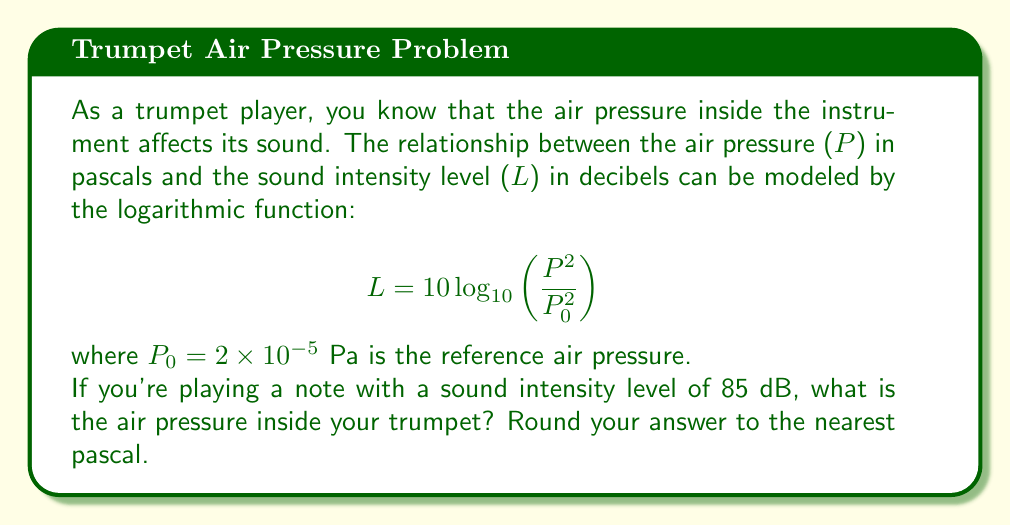Solve this math problem. Let's approach this step-by-step:

1) We're given the formula:
   $$ L = 10 \log_{10}\left(\frac{P^2}{P_0^2}\right) $$

2) We know that:
   - $L = 85$ dB (the sound intensity level)
   - $P_0 = 2 \times 10^{-5}$ Pa (the reference air pressure)
   - We need to solve for $P$

3) Let's substitute the known values into the equation:
   $$ 85 = 10 \log_{10}\left(\frac{P^2}{(2 \times 10^{-5})^2}\right) $$

4) Divide both sides by 10:
   $$ 8.5 = \log_{10}\left(\frac{P^2}{4 \times 10^{-10}}\right) $$

5) Now, we can apply the inverse function (10 to the power) to both sides:
   $$ 10^{8.5} = \frac{P^2}{4 \times 10^{-10}} $$

6) Multiply both sides by $4 \times 10^{-10}$:
   $$ 4 \times 10^{-10} \times 10^{8.5} = P^2 $$

7) Simplify:
   $$ 4 \times 10^{-1.5} = P^2 $$

8) Take the square root of both sides:
   $$ P = \sqrt{4 \times 10^{-1.5}} = 2 \times 10^{-0.75} $$

9) Calculate this value:
   $$ P \approx 0.3557 \text{ Pa} $$

10) Rounding to the nearest pascal:
    $$ P \approx 0 \text{ Pa} $$
Answer: 0 Pa 